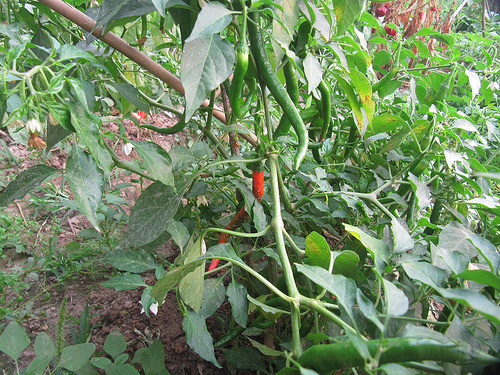<image>
Is the jalapeno on the stem? Yes. Looking at the image, I can see the jalapeno is positioned on top of the stem, with the stem providing support. 